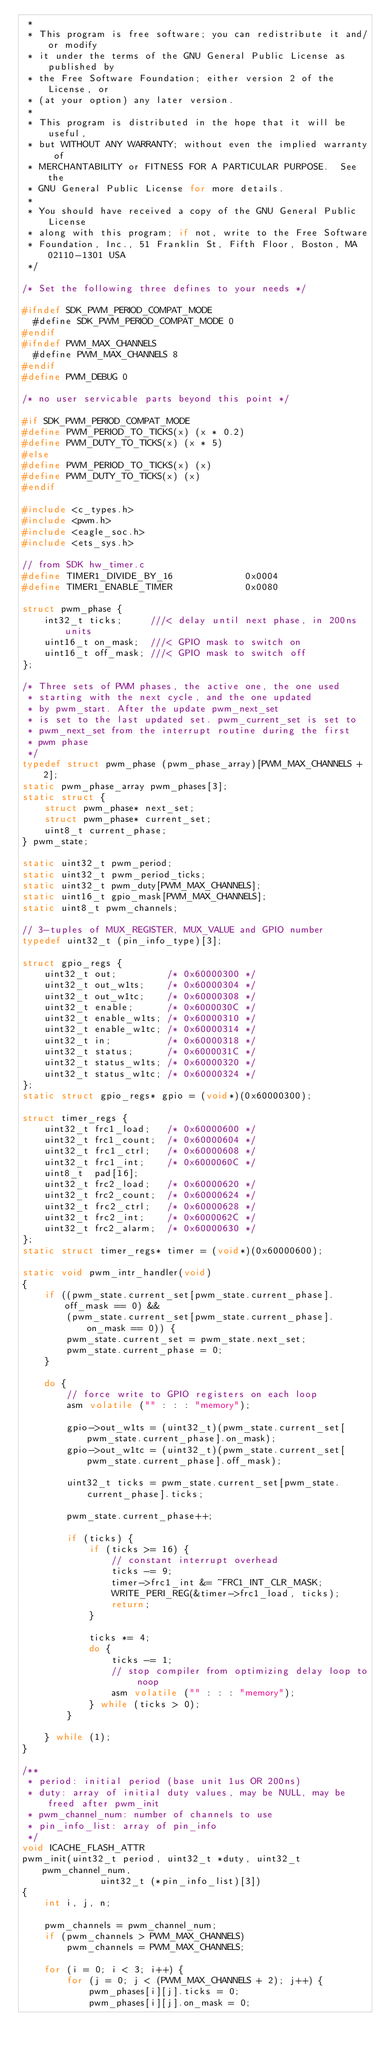Convert code to text. <code><loc_0><loc_0><loc_500><loc_500><_C_> *
 * This program is free software; you can redistribute it and/or modify
 * it under the terms of the GNU General Public License as published by
 * the Free Software Foundation; either version 2 of the License, or
 * (at your option) any later version.
 *
 * This program is distributed in the hope that it will be useful,
 * but WITHOUT ANY WARRANTY; without even the implied warranty of
 * MERCHANTABILITY or FITNESS FOR A PARTICULAR PURPOSE.  See the
 * GNU General Public License for more details.
 *
 * You should have received a copy of the GNU General Public License
 * along with this program; if not, write to the Free Software
 * Foundation, Inc., 51 Franklin St, Fifth Floor, Boston, MA  02110-1301 USA
 */

/* Set the following three defines to your needs */

#ifndef SDK_PWM_PERIOD_COMPAT_MODE
  #define SDK_PWM_PERIOD_COMPAT_MODE 0
#endif
#ifndef PWM_MAX_CHANNELS
  #define PWM_MAX_CHANNELS 8
#endif
#define PWM_DEBUG 0

/* no user servicable parts beyond this point */

#if SDK_PWM_PERIOD_COMPAT_MODE
#define PWM_PERIOD_TO_TICKS(x) (x * 0.2)
#define PWM_DUTY_TO_TICKS(x) (x * 5)
#else
#define PWM_PERIOD_TO_TICKS(x) (x)
#define PWM_DUTY_TO_TICKS(x) (x)
#endif

#include <c_types.h>
#include <pwm.h>
#include <eagle_soc.h>
#include <ets_sys.h>

// from SDK hw_timer.c
#define TIMER1_DIVIDE_BY_16             0x0004
#define TIMER1_ENABLE_TIMER             0x0080

struct pwm_phase {
	int32_t ticks;     ///< delay until next phase, in 200ns units
	uint16_t on_mask;  ///< GPIO mask to switch on
	uint16_t off_mask; ///< GPIO mask to switch off
};

/* Three sets of PWM phases, the active one, the one used
 * starting with the next cycle, and the one updated
 * by pwm_start. After the update pwm_next_set
 * is set to the last updated set. pwm_current_set is set to
 * pwm_next_set from the interrupt routine during the first
 * pwm phase
 */
typedef struct pwm_phase (pwm_phase_array)[PWM_MAX_CHANNELS + 2];
static pwm_phase_array pwm_phases[3];
static struct {
	struct pwm_phase* next_set;
	struct pwm_phase* current_set;
	uint8_t current_phase;
} pwm_state;

static uint32_t pwm_period;
static uint32_t pwm_period_ticks;
static uint32_t pwm_duty[PWM_MAX_CHANNELS];
static uint16_t gpio_mask[PWM_MAX_CHANNELS];
static uint8_t pwm_channels;

// 3-tuples of MUX_REGISTER, MUX_VALUE and GPIO number
typedef uint32_t (pin_info_type)[3];

struct gpio_regs {
	uint32_t out;         /* 0x60000300 */
	uint32_t out_w1ts;    /* 0x60000304 */
	uint32_t out_w1tc;    /* 0x60000308 */
	uint32_t enable;      /* 0x6000030C */
	uint32_t enable_w1ts; /* 0x60000310 */
	uint32_t enable_w1tc; /* 0x60000314 */
	uint32_t in;          /* 0x60000318 */
	uint32_t status;      /* 0x6000031C */
	uint32_t status_w1ts; /* 0x60000320 */
	uint32_t status_w1tc; /* 0x60000324 */
};
static struct gpio_regs* gpio = (void*)(0x60000300);

struct timer_regs {
	uint32_t frc1_load;   /* 0x60000600 */
	uint32_t frc1_count;  /* 0x60000604 */
	uint32_t frc1_ctrl;   /* 0x60000608 */
	uint32_t frc1_int;    /* 0x6000060C */
	uint8_t  pad[16];
	uint32_t frc2_load;   /* 0x60000620 */
	uint32_t frc2_count;  /* 0x60000624 */
	uint32_t frc2_ctrl;   /* 0x60000628 */
	uint32_t frc2_int;    /* 0x6000062C */
	uint32_t frc2_alarm;  /* 0x60000630 */
};
static struct timer_regs* timer = (void*)(0x60000600);

static void pwm_intr_handler(void)
{
	if ((pwm_state.current_set[pwm_state.current_phase].off_mask == 0) &&
	    (pwm_state.current_set[pwm_state.current_phase].on_mask == 0)) {
		pwm_state.current_set = pwm_state.next_set;
		pwm_state.current_phase = 0;
	}

	do {
		// force write to GPIO registers on each loop
		asm volatile ("" : : : "memory");

		gpio->out_w1ts = (uint32_t)(pwm_state.current_set[pwm_state.current_phase].on_mask);
		gpio->out_w1tc = (uint32_t)(pwm_state.current_set[pwm_state.current_phase].off_mask);

		uint32_t ticks = pwm_state.current_set[pwm_state.current_phase].ticks;

		pwm_state.current_phase++;

		if (ticks) {
			if (ticks >= 16) {
				// constant interrupt overhead
				ticks -= 9;
				timer->frc1_int &= ~FRC1_INT_CLR_MASK;
				WRITE_PERI_REG(&timer->frc1_load, ticks);
				return;
			}

			ticks *= 4;
			do {
				ticks -= 1;
				// stop compiler from optimizing delay loop to noop
				asm volatile ("" : : : "memory");
			} while (ticks > 0);
		}

	} while (1);
}

/**
 * period: initial period (base unit 1us OR 200ns)
 * duty: array of initial duty values, may be NULL, may be freed after pwm_init
 * pwm_channel_num: number of channels to use
 * pin_info_list: array of pin_info
 */
void ICACHE_FLASH_ATTR
pwm_init(uint32_t period, uint32_t *duty, uint32_t pwm_channel_num,
              uint32_t (*pin_info_list)[3])
{
	int i, j, n;

	pwm_channels = pwm_channel_num;
	if (pwm_channels > PWM_MAX_CHANNELS)
		pwm_channels = PWM_MAX_CHANNELS;

	for (i = 0; i < 3; i++) {
		for (j = 0; j < (PWM_MAX_CHANNELS + 2); j++) {
			pwm_phases[i][j].ticks = 0;
			pwm_phases[i][j].on_mask = 0;</code> 